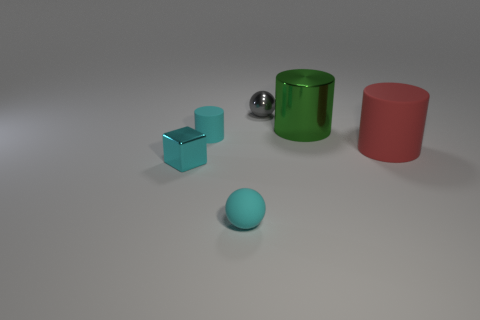Are there any other things that are the same size as the cyan block?
Provide a short and direct response. Yes. There is a block that is the same color as the matte ball; what is it made of?
Make the answer very short. Metal. Is the color of the small cube the same as the small matte sphere?
Provide a short and direct response. Yes. What number of other things are there of the same color as the small cylinder?
Your response must be concise. 2. Is the color of the metallic object in front of the big matte cylinder the same as the small thing that is in front of the block?
Ensure brevity in your answer.  Yes. What size is the cyan rubber thing that is the same shape as the big red matte object?
Your response must be concise. Small. Are there more gray balls that are behind the green shiny cylinder than small gray blocks?
Offer a terse response. Yes. Is the large cylinder that is in front of the green cylinder made of the same material as the cyan cylinder?
Your answer should be very brief. Yes. There is a thing that is behind the green object behind the big cylinder that is in front of the large shiny cylinder; what size is it?
Your response must be concise. Small. What is the size of the sphere that is made of the same material as the tiny cyan cylinder?
Give a very brief answer. Small. 